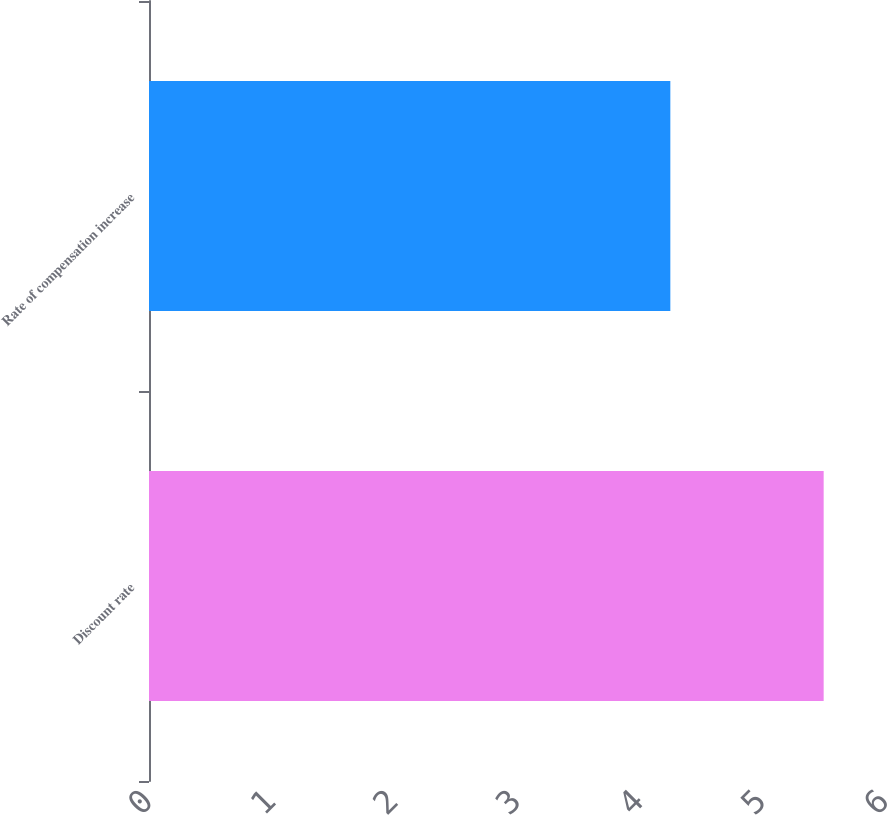Convert chart to OTSL. <chart><loc_0><loc_0><loc_500><loc_500><bar_chart><fcel>Discount rate<fcel>Rate of compensation increase<nl><fcel>5.5<fcel>4.25<nl></chart> 